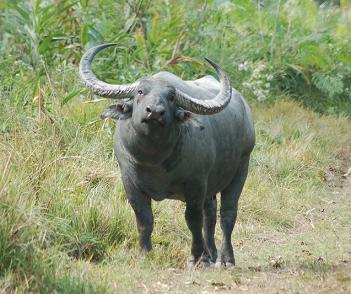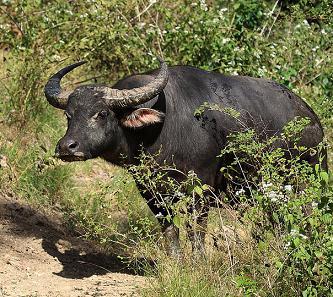The first image is the image on the left, the second image is the image on the right. Assess this claim about the two images: "Two animals are standing in the grass in one of the pictures.". Correct or not? Answer yes or no. No. The first image is the image on the left, the second image is the image on the right. Considering the images on both sides, is "There are 3 animals in the images" valid? Answer yes or no. No. 